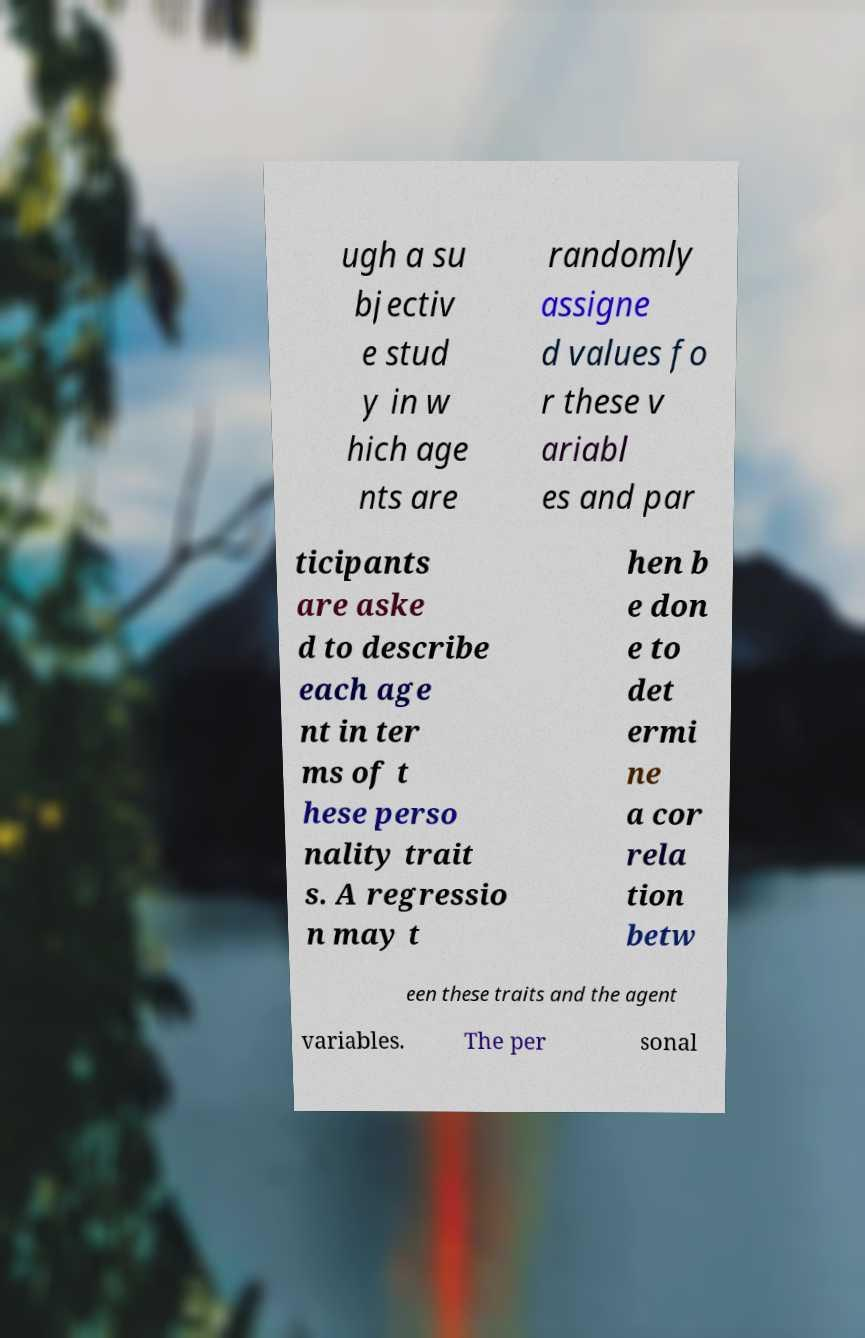Could you assist in decoding the text presented in this image and type it out clearly? ugh a su bjectiv e stud y in w hich age nts are randomly assigne d values fo r these v ariabl es and par ticipants are aske d to describe each age nt in ter ms of t hese perso nality trait s. A regressio n may t hen b e don e to det ermi ne a cor rela tion betw een these traits and the agent variables. The per sonal 